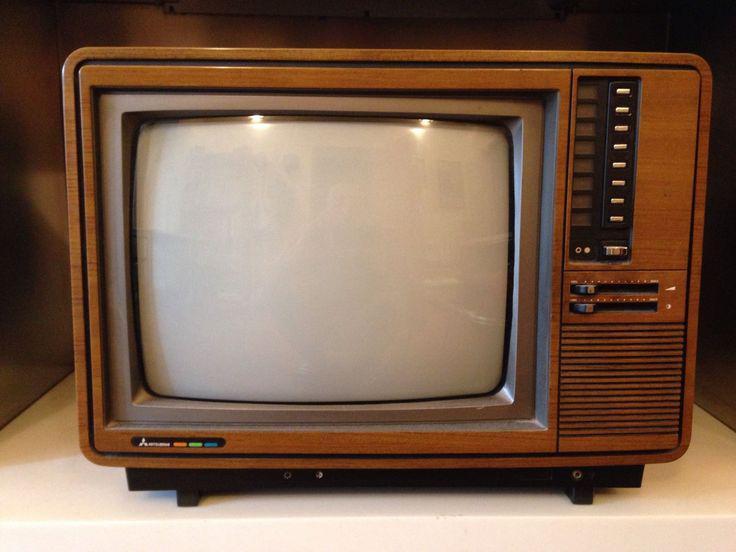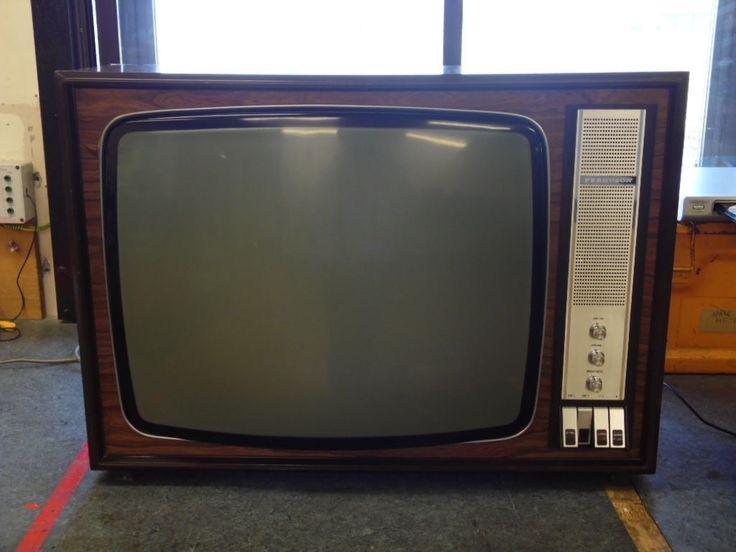The first image is the image on the left, the second image is the image on the right. Examine the images to the left and right. Is the description "The television in the image on the left has a woodgrain finish." accurate? Answer yes or no. Yes. 